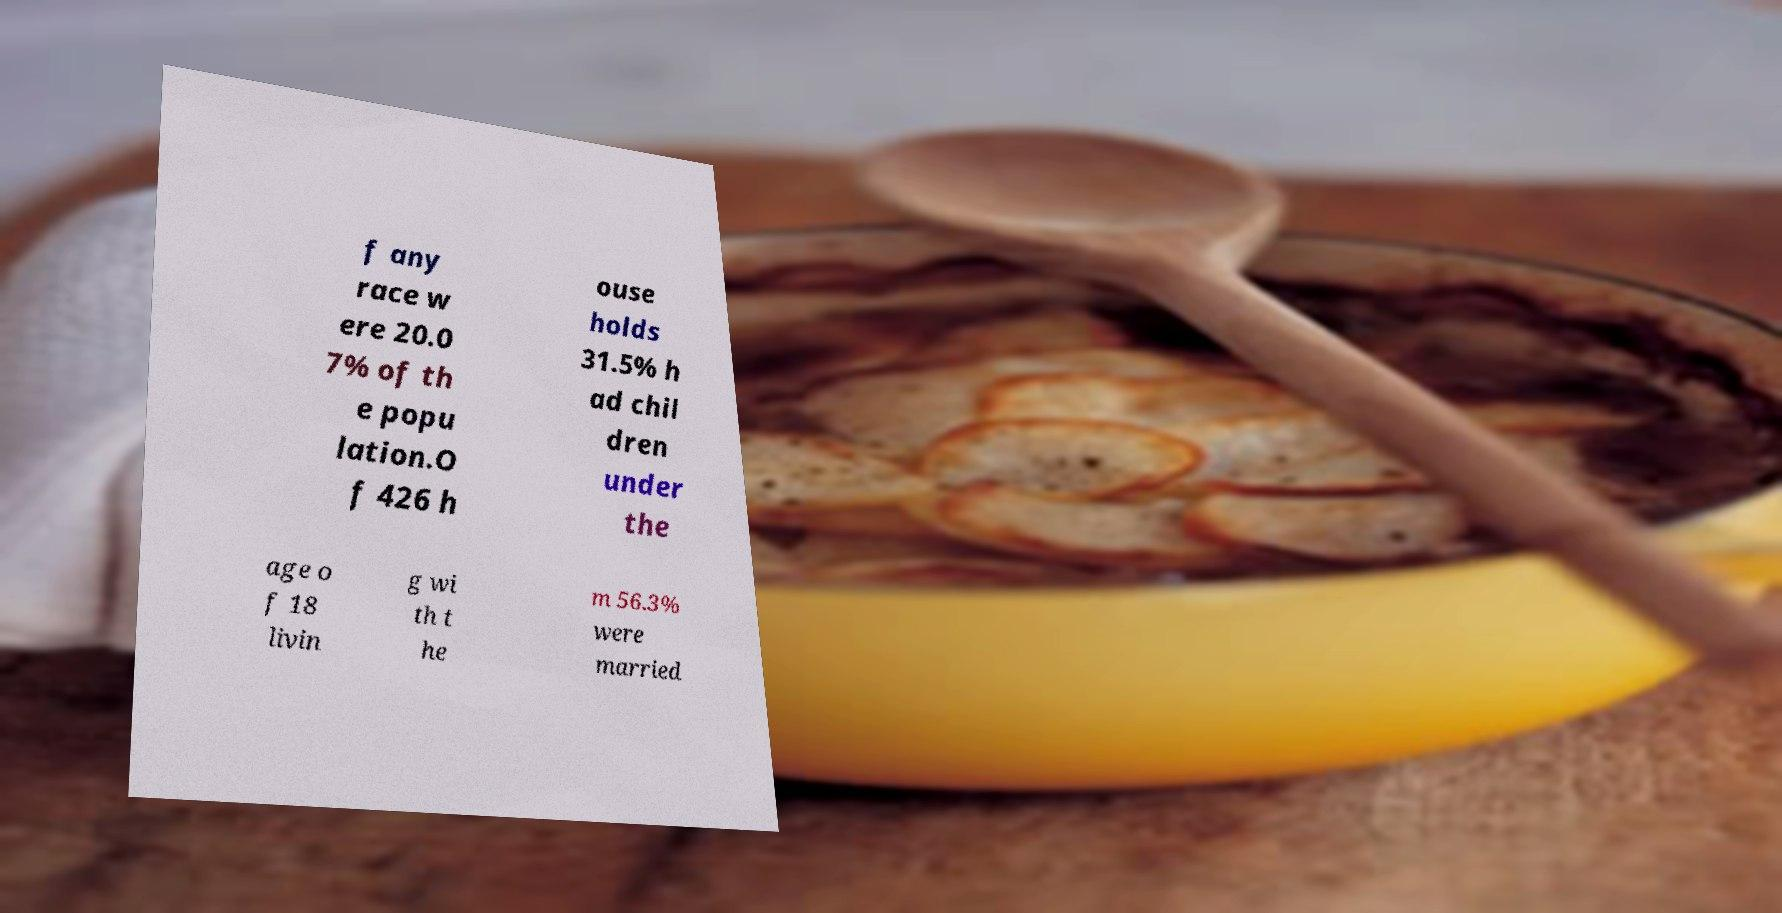Please identify and transcribe the text found in this image. f any race w ere 20.0 7% of th e popu lation.O f 426 h ouse holds 31.5% h ad chil dren under the age o f 18 livin g wi th t he m 56.3% were married 